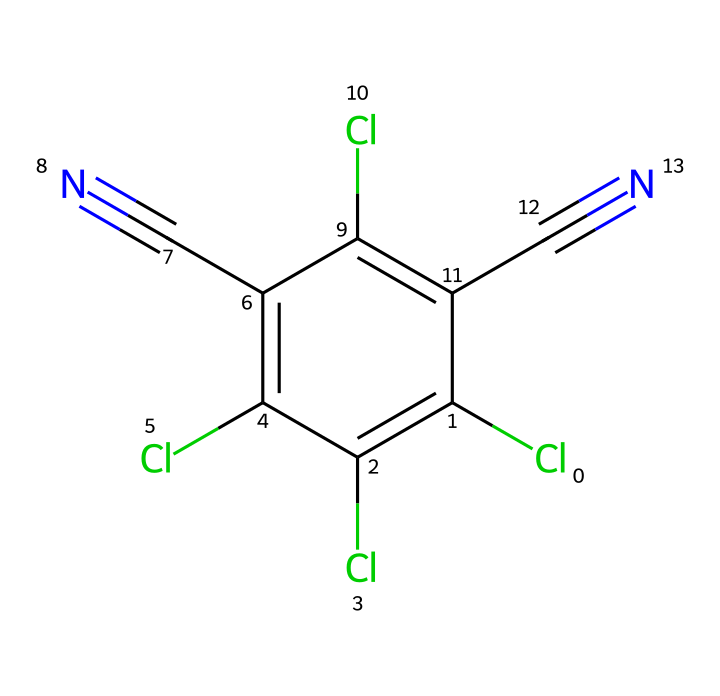What is the molecular formula of chlorothalonil? To find the molecular formula, count the atoms of each element in the SMILES representation. The SMILES indicates 2 carbon atoms, 6 chlorine atoms, and 2 nitrogen atoms, leading to the formula C8Cl4N2.
Answer: C8Cl4N2 How many chlorine atoms are present in chlorothalonil? By examining the SMILES notation, we can identify that there are 6 instances of 'Cl', indicating there are 6 chlorine atoms.
Answer: 6 What is the role of chlorothalonil in agriculture? Chlorothalonil functions primarily as a fungicide, used to control fungal diseases in crops and turf management. Its mechanism involves inhibiting fungal respiration and growth.
Answer: fungicide How many triple bonds are present in chlorothalonil? The notation 'C#N' appears twice in the SMILES, indicating there are 2 triple bonds in chlorothalonil, specifically between carbon and nitrogen.
Answer: 2 Which element in chlorothalonil is responsible for its toxicity? Chlorine is typically associated with toxicity in many compounds, and since it's present in significant amounts (6 atoms), it is responsible for the toxic effects.
Answer: chlorine What type of bonding is exhibited in the triple bond of chlorothalonil? The triple bond consists of one sigma bond and two pi bonds, which are characteristic of carbon-nitrogen interactions seen in 'C#N'. Therefore, the type of bonding is considered a covalent bond.
Answer: covalent bond How many aromatic rings are present in chlorothalonil? The structure represented in the SMILES indicates that there is one benzene-like structure with alternating double bonds, which is recognized as an aromatic ring.
Answer: 1 